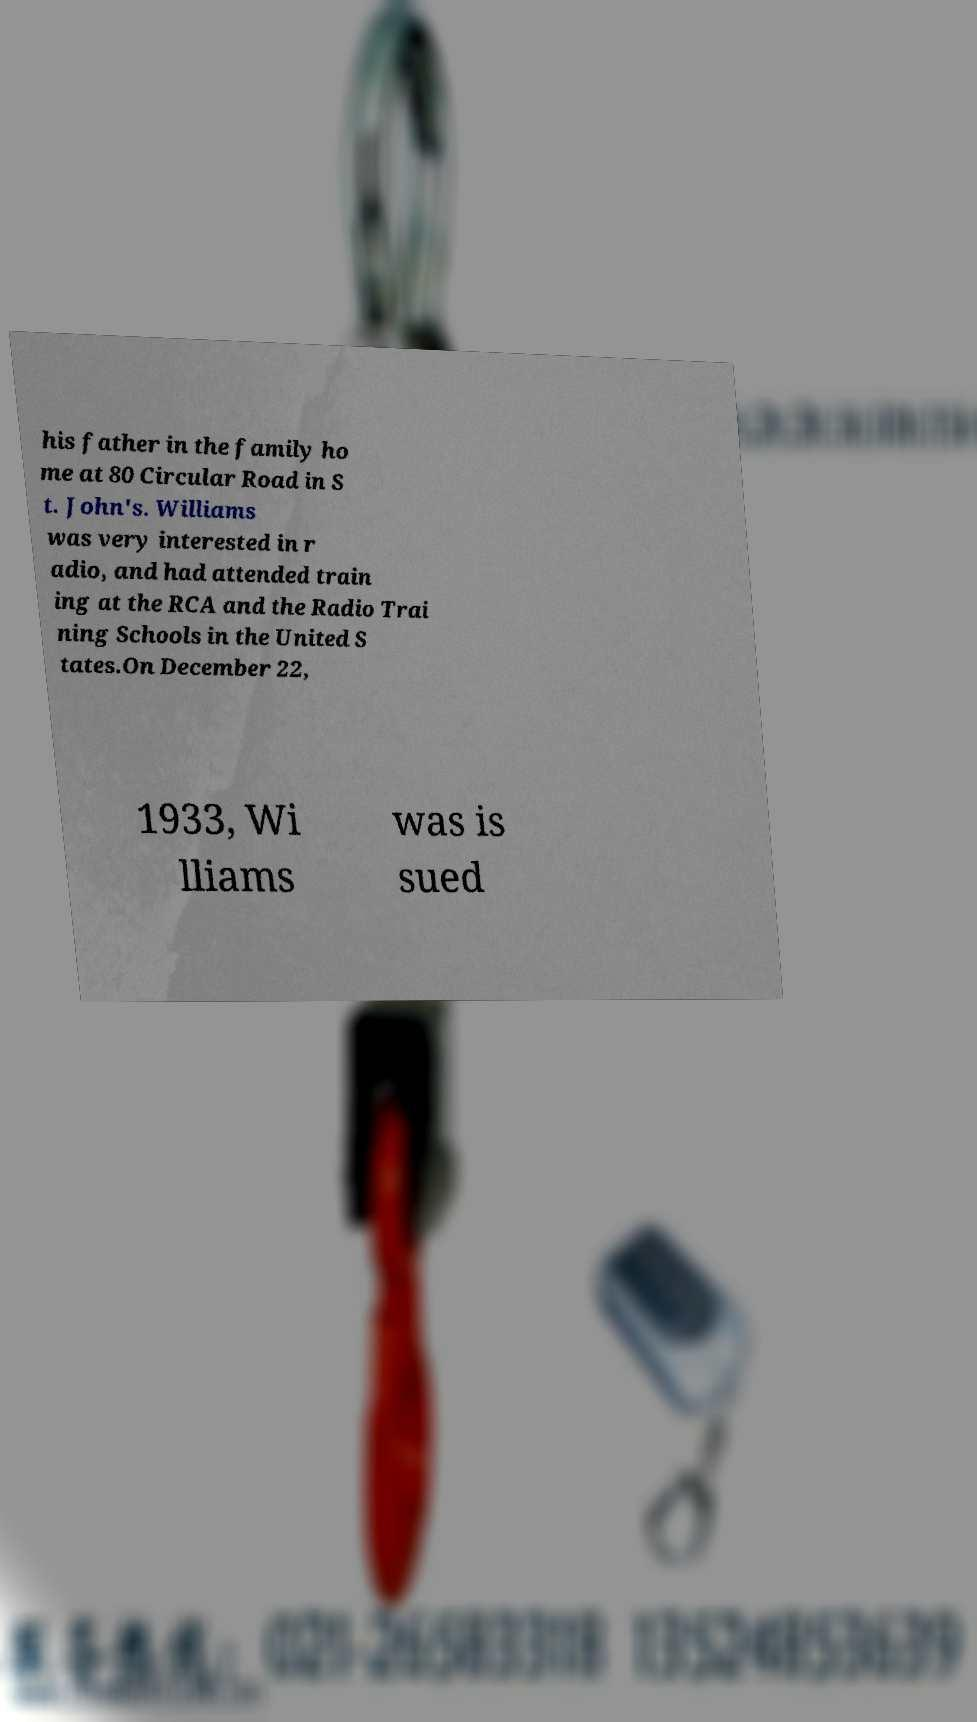I need the written content from this picture converted into text. Can you do that? his father in the family ho me at 80 Circular Road in S t. John's. Williams was very interested in r adio, and had attended train ing at the RCA and the Radio Trai ning Schools in the United S tates.On December 22, 1933, Wi lliams was is sued 